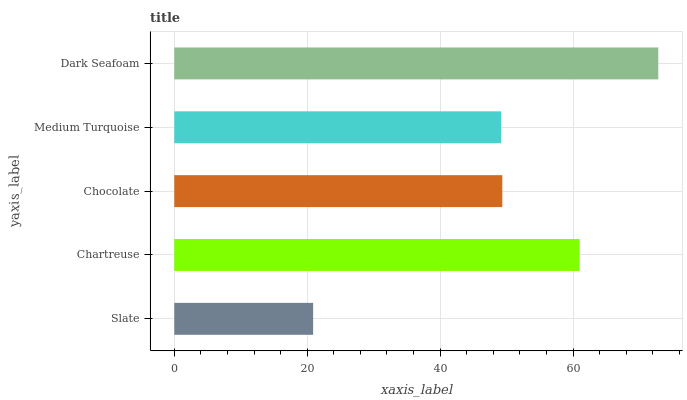Is Slate the minimum?
Answer yes or no. Yes. Is Dark Seafoam the maximum?
Answer yes or no. Yes. Is Chartreuse the minimum?
Answer yes or no. No. Is Chartreuse the maximum?
Answer yes or no. No. Is Chartreuse greater than Slate?
Answer yes or no. Yes. Is Slate less than Chartreuse?
Answer yes or no. Yes. Is Slate greater than Chartreuse?
Answer yes or no. No. Is Chartreuse less than Slate?
Answer yes or no. No. Is Chocolate the high median?
Answer yes or no. Yes. Is Chocolate the low median?
Answer yes or no. Yes. Is Chartreuse the high median?
Answer yes or no. No. Is Chartreuse the low median?
Answer yes or no. No. 